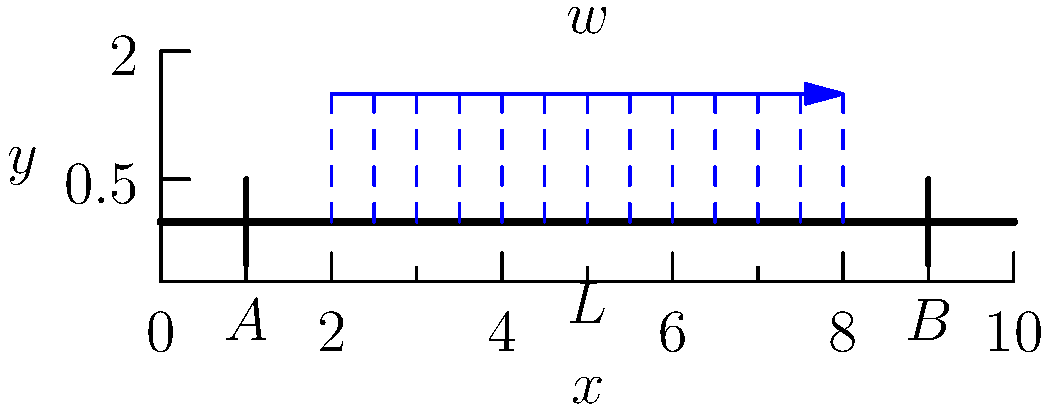A simply supported beam of length $L$ is subjected to a uniformly distributed load $w$ over the middle 60% of its span. Determine the maximum bending moment in the beam and its location. To solve this problem, let's follow these steps:

1) First, we need to determine the reactions at the supports:
   Due to symmetry, $R_A = R_B = 0.6wL/2 = 0.3wL$

2) The maximum bending moment will occur where the shear force is zero. 
   Due to symmetry, this will be at the center of the beam.

3) To calculate the maximum bending moment, we can consider half of the beam:
   $M_{max} = R_A \cdot 0.5L - w \cdot 0.3L \cdot 0.15L$
   
   Here, $0.3L$ is half of the loaded length, and $0.15L$ is the distance from the support to the center of the loaded area.

4) Substituting the value of $R_A$:
   $M_{max} = 0.3wL \cdot 0.5L - w \cdot 0.3L \cdot 0.15L$
   $M_{max} = 0.15wL^2 - 0.045wL^2$
   $M_{max} = 0.105wL^2$

5) The location of the maximum bending moment is at the center of the beam, i.e., at $x = 0.5L$.
Answer: $M_{max} = 0.105wL^2$ at $x = 0.5L$ 